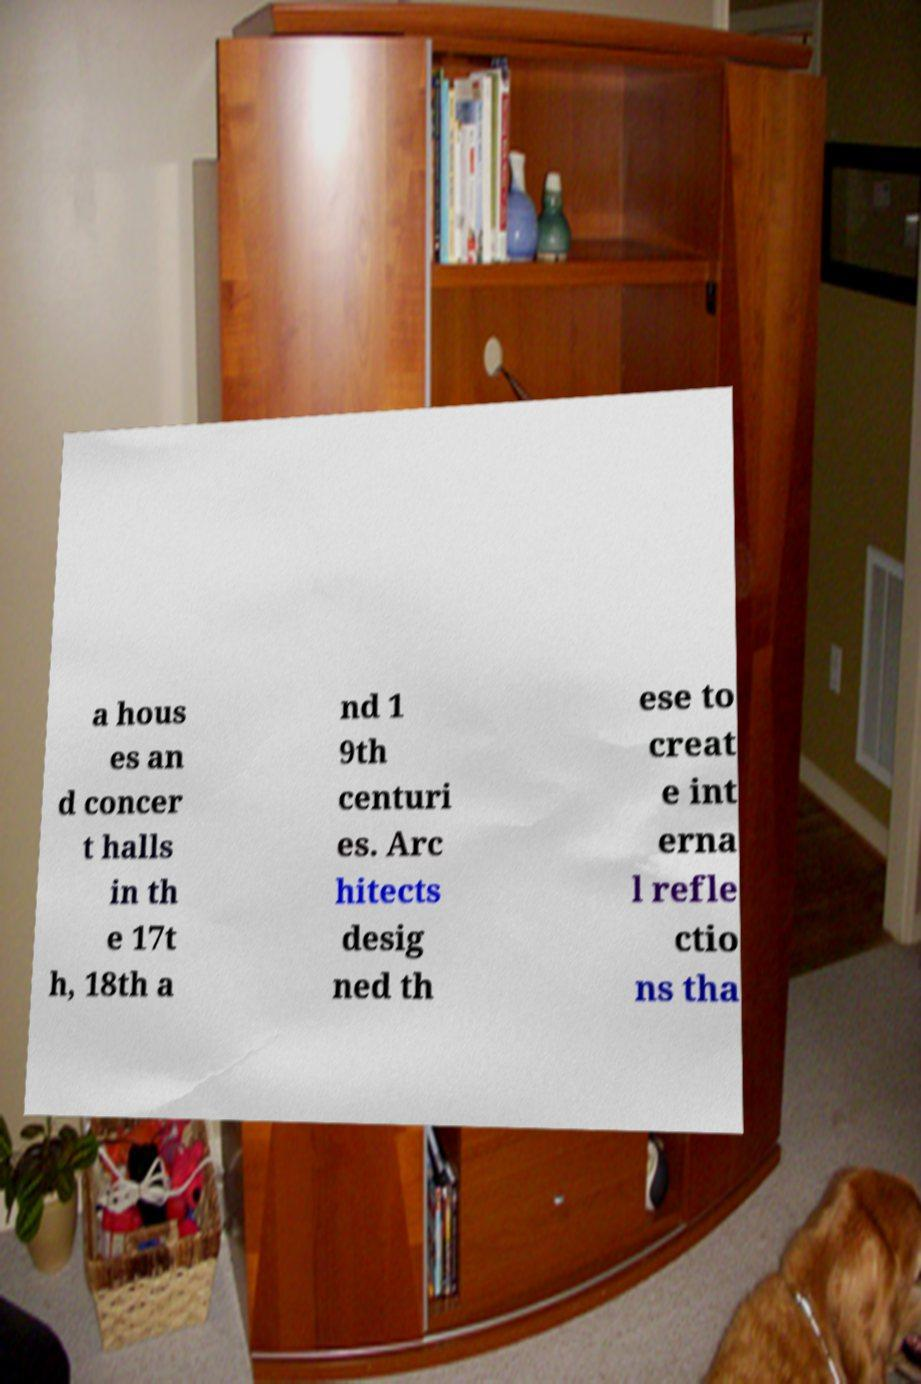There's text embedded in this image that I need extracted. Can you transcribe it verbatim? a hous es an d concer t halls in th e 17t h, 18th a nd 1 9th centuri es. Arc hitects desig ned th ese to creat e int erna l refle ctio ns tha 